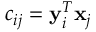<formula> <loc_0><loc_0><loc_500><loc_500>c _ { i j } = y _ { i } ^ { T } x _ { j }</formula> 